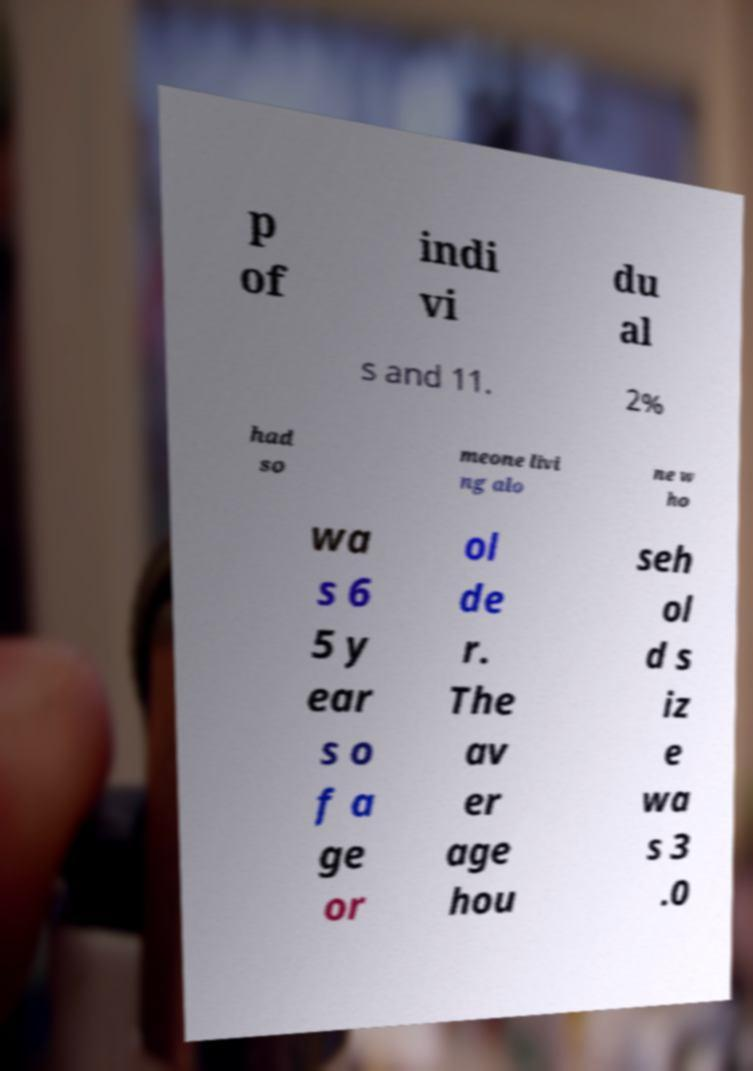Could you extract and type out the text from this image? p of indi vi du al s and 11. 2% had so meone livi ng alo ne w ho wa s 6 5 y ear s o f a ge or ol de r. The av er age hou seh ol d s iz e wa s 3 .0 